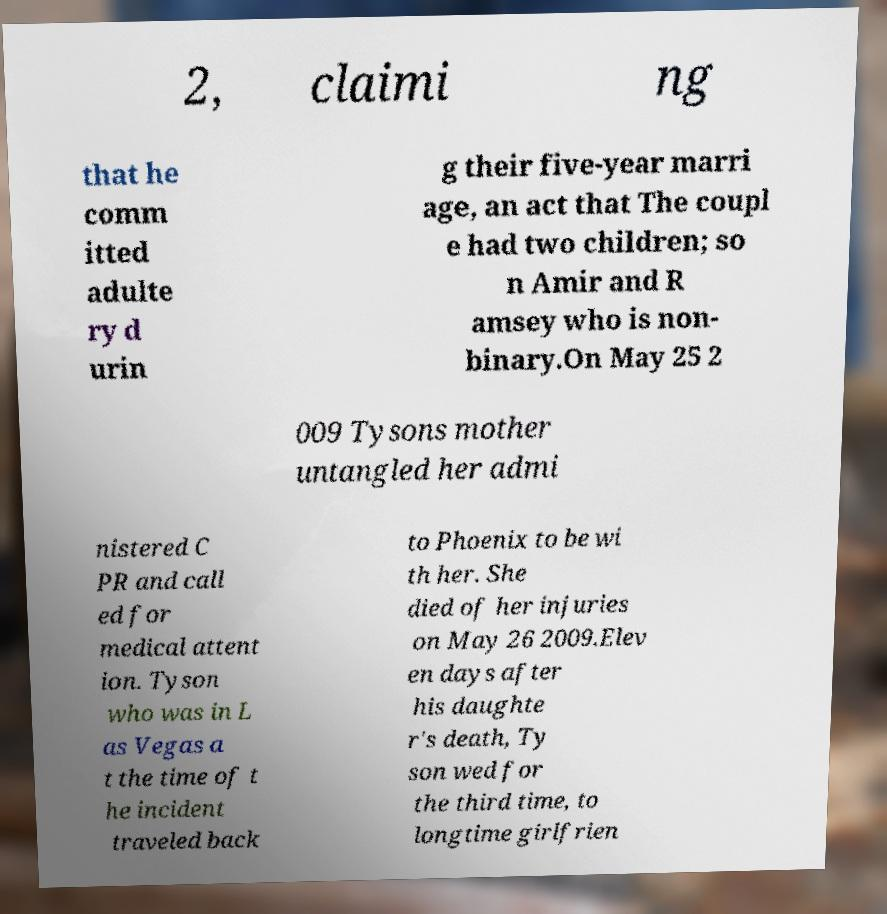I need the written content from this picture converted into text. Can you do that? 2, claimi ng that he comm itted adulte ry d urin g their five-year marri age, an act that The coupl e had two children; so n Amir and R amsey who is non- binary.On May 25 2 009 Tysons mother untangled her admi nistered C PR and call ed for medical attent ion. Tyson who was in L as Vegas a t the time of t he incident traveled back to Phoenix to be wi th her. She died of her injuries on May 26 2009.Elev en days after his daughte r's death, Ty son wed for the third time, to longtime girlfrien 